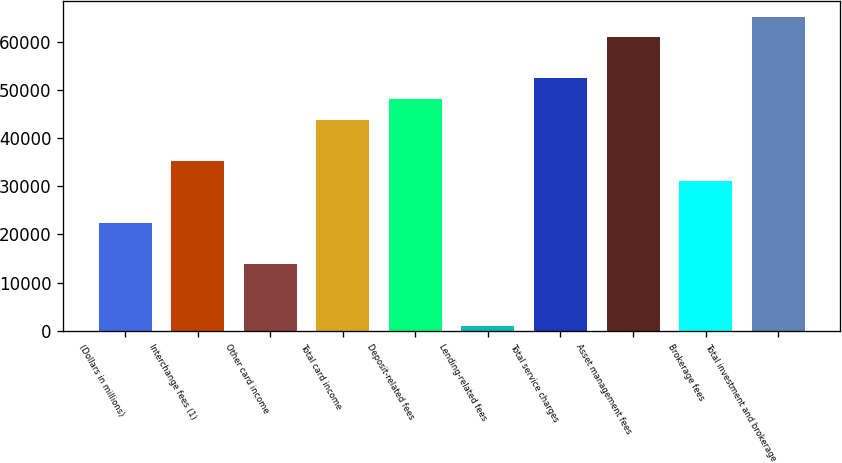<chart> <loc_0><loc_0><loc_500><loc_500><bar_chart><fcel>(Dollars in millions)<fcel>Interchange fees (1)<fcel>Other card income<fcel>Total card income<fcel>Deposit-related fees<fcel>Lending-related fees<fcel>Total service charges<fcel>Asset management fees<fcel>Brokerage fees<fcel>Total investment and brokerage<nl><fcel>22457.5<fcel>35272<fcel>13914.5<fcel>43815<fcel>48086.5<fcel>1100<fcel>52358<fcel>60901<fcel>31000.5<fcel>65172.5<nl></chart> 